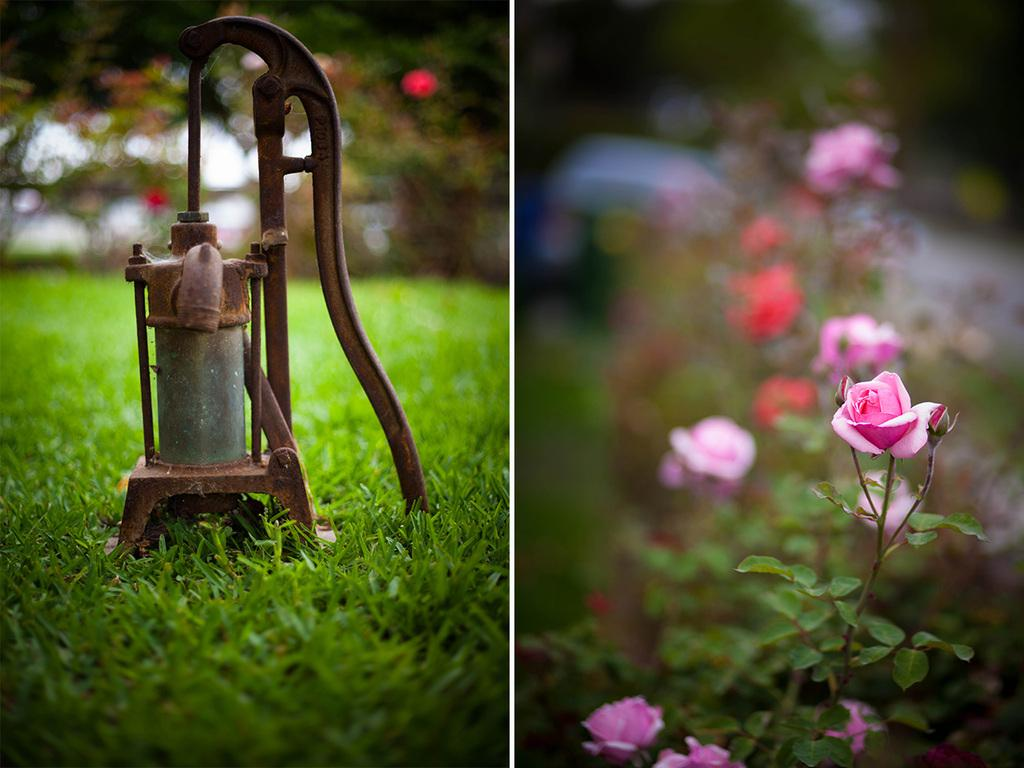What can be found on the left side of the image? There is a hand pump on the left side of the image. What is the hand pump placed on? The hand pump is on the grass. What type of flowers are on the right side of the image? There are beautiful rose flowers on the right side of the image. What else is present on the right side of the image besides the flowers? There are plants on the right side of the image. Can you see any ants crawling on the hand pump in the image? There is no mention of ants in the image, so we cannot determine if they are present or not. Is the hand pump in motion in the image? No, the hand pump is stationary in the image. 